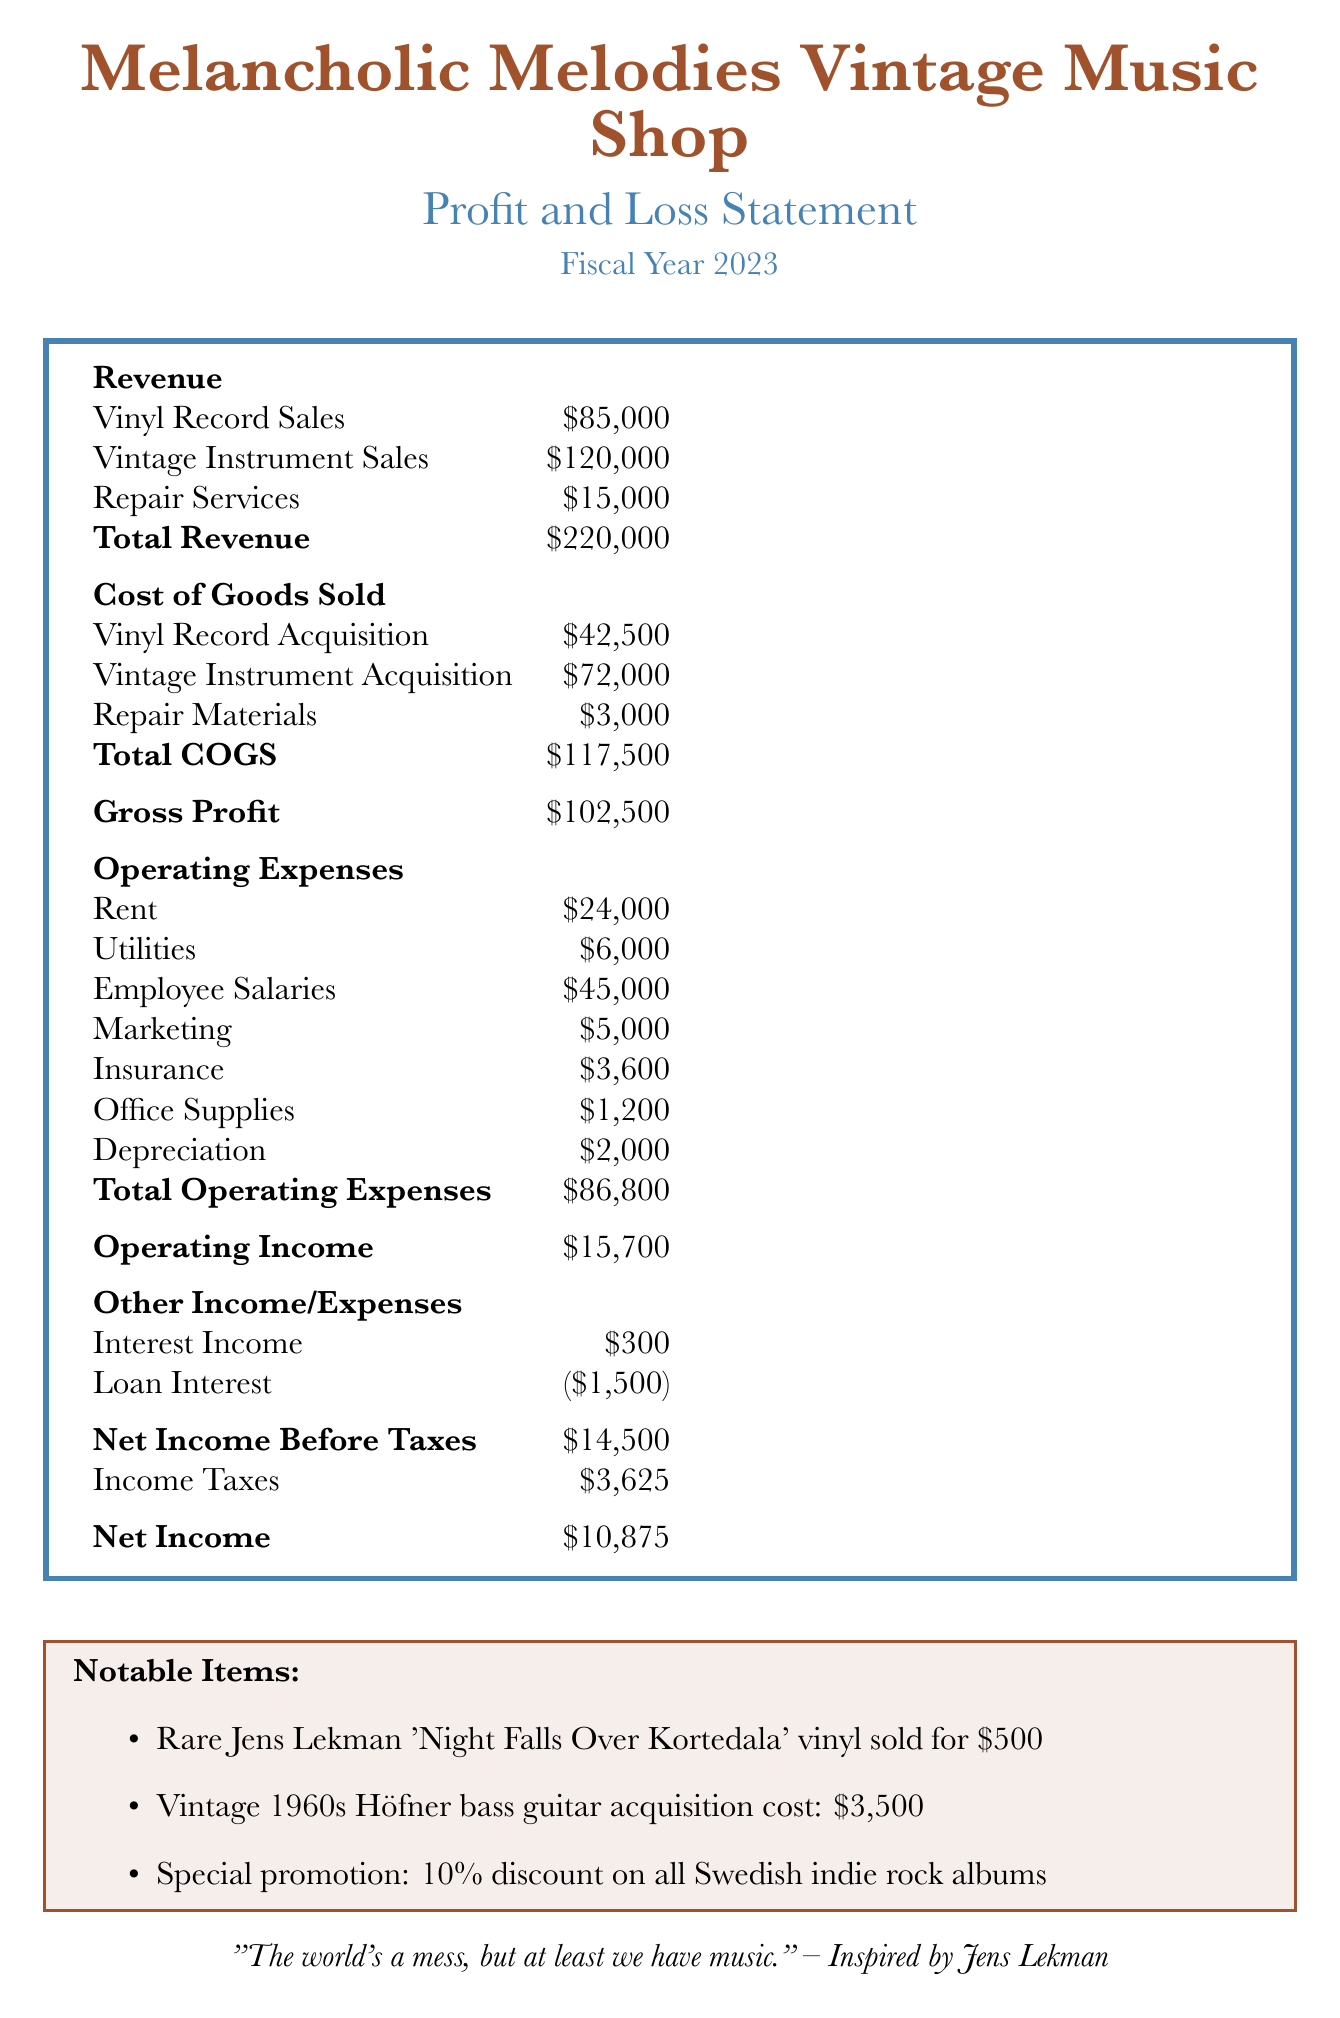what is the total revenue? The total revenue is stated in the document as the sum of all revenue streams, which is $85,000 from vinyl record sales, $120,000 from vintage instrument sales, and $15,000 from repair services.
Answer: $220,000 what are the operating expenses? The total operating expenses include costs such as rent, utilities, salaries, marketing, insurance, office supplies, and depreciation, which sum up to $86,800.
Answer: $86,800 how much did the business earn from vintage instrument sales? The document specifies the amount earned from vintage instrument sales, which is $120,000.
Answer: $120,000 what is the net income after taxes? The net income after taxes is calculated by subtracting the income taxes from the net income before taxes. The net income is reported as $10,875.
Answer: $10,875 what is the acquisition cost of the vintage 1960s Höfner bass guitar? The document lists the acquisition cost of the vintage 1960s Höfner bass guitar as $3,500.
Answer: $3,500 how much interest income did the business receive? The amount received in interest income is specified in the document as $300.
Answer: $300 what is the amount of loan interest incurred? The document indicates that the loan interest incurred is $1,500.
Answer: $1,500 how much was gross profit? Gross profit is calculated from total revenue minus total cost of goods sold, which is reported as $102,500.
Answer: $102,500 what notable item sold for $500? According to the document, the rare Jens Lekman 'Night Falls Over Kortedala' vinyl sold for $500.
Answer: Rare Jens Lekman 'Night Falls Over Kortedala' vinyl 